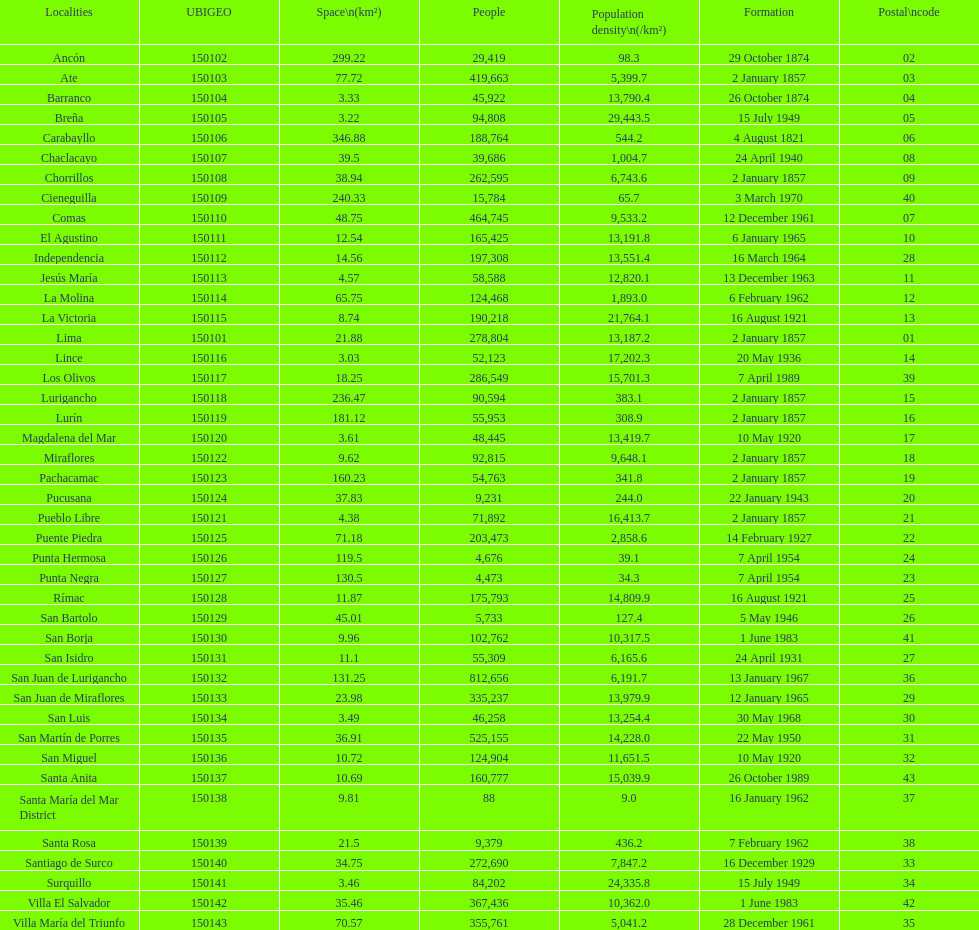How many districts have more than 100,000 people in this city? 21. 